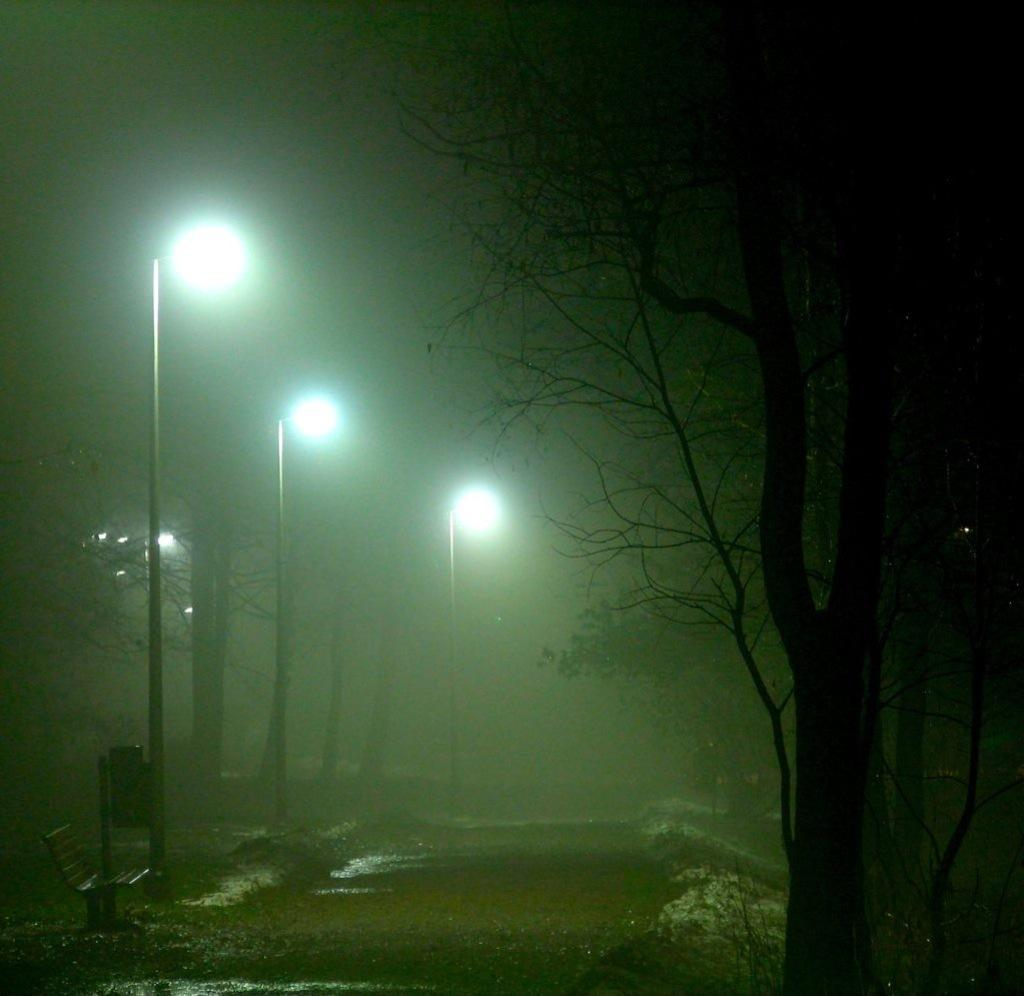How many poles are present in the image? There are three poles in the image. What is attached to the poles? There are lights on the poles. What type of seating is located at the left bottom of the image? There is a bench at the left bottom of the image. What can be seen on the right side of the image? There are trees visible on the right side of the image. Can you tell me how many tigers are sitting on the bench in the image? There are no tigers present in the image; it only features poles, lights, a bench, and trees. What type of stitch is used to attach the lights to the poles? The image does not provide information about the type of stitch used to attach the lights to the poles. 